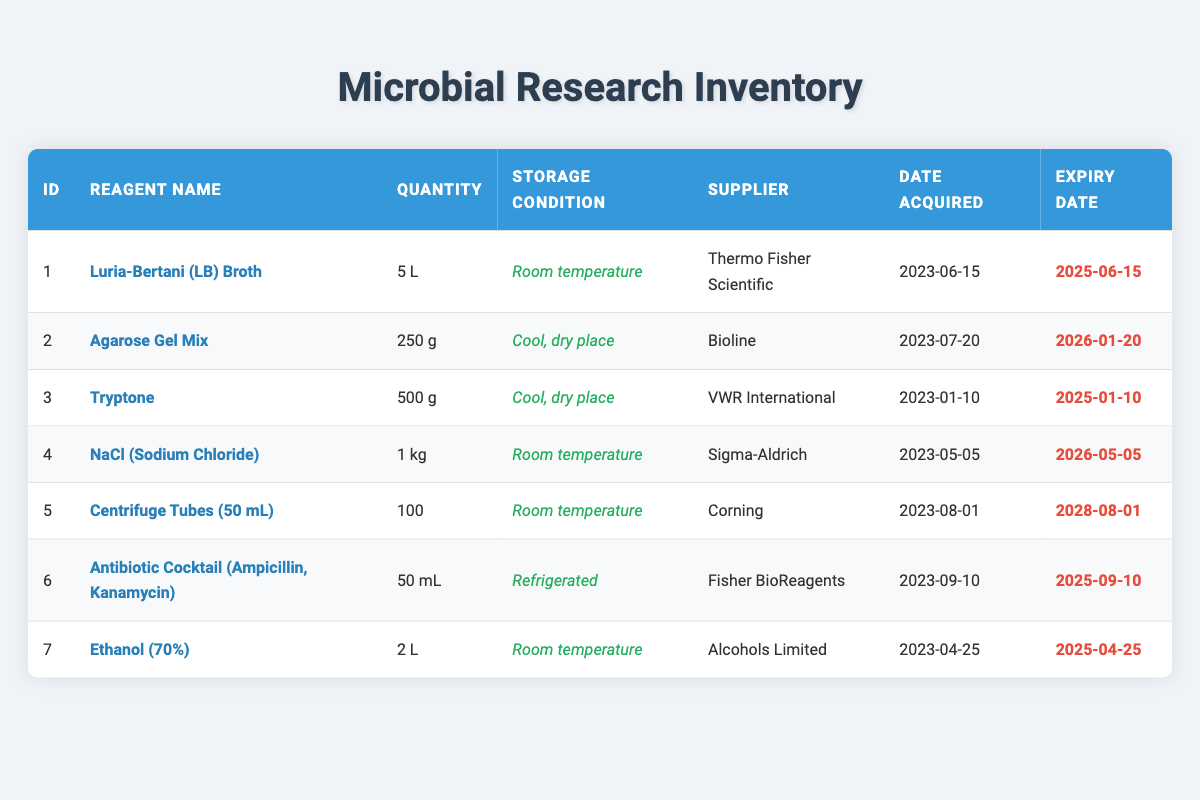What is the quantity of NaCl (Sodium Chloride) in the inventory? The table indicates that the quantity of NaCl (Sodium Chloride) is 1 kg, as listed under the quantity column for row ID 4.
Answer: 1 kg Which supplier provided the Agarose Gel Mix? According to the table, the supplier for Agarose Gel Mix, found in row ID 2, is Bioline.
Answer: Bioline How many types of reagents are stored at room temperature? By examining the storage condition column, I find that Luria-Bertani (LB) Broth, NaCl (Sodium Chloride), Centrifuge Tubes (50 mL), Ethanol (70%) are all stored at room temperature. Therefore, there are a total of 4 types.
Answer: 4 Is the expiry date for Tryptone before or after January 10, 2025? The expiry date provided in the table for Tryptone is January 10, 2025. Since the date matches the comparison date, the result is that it is the same date, hence it is not before January 10, 2025.
Answer: No What is the total quantity of liquid reagents in liters? The liquid reagents are Luria-Bertani (LB) Broth (5 L), Ethanol (70%) (2 L), and the Antibiotic Cocktail (50 mL, which converts to 0.05 L). Adding these values gives 5 + 2 + 0.05 = 7.05 liters.
Answer: 7.05 L Which reagent has the latest expiry date? The expiry dates are compared for all reagents, finding that the Centrifuge Tubes (50 mL) expire on August 1, 2028, which is the furthest date in the table.
Answer: Centrifuge Tubes (50 mL) Are all suppliers from the same country? Examining the suppliers in the table, we have Thermo Fisher Scientific, Bioline, VWR International, Sigma-Aldrich, Corning, Fisher BioReagents, and Alcohols Limited, which are not all from the same country. Hence the statement is false.
Answer: No What is the difference in quantity between the largest and smallest reagent in grams? The largest quantity in grams is NaCl (Sodium Chloride) with 1000 grams, and the smallest quantity among solid reagents is Agarose Gel Mix with 250 grams. The difference is 1000 - 250 = 750 grams.
Answer: 750 g 